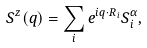Convert formula to latex. <formula><loc_0><loc_0><loc_500><loc_500>S ^ { z } ( q ) = \sum _ { i } e ^ { i q \cdot R _ { i } } S _ { i } ^ { \alpha } ,</formula> 